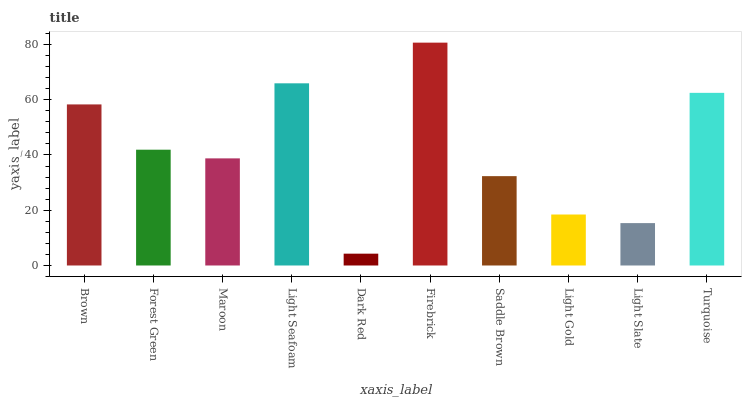Is Dark Red the minimum?
Answer yes or no. Yes. Is Firebrick the maximum?
Answer yes or no. Yes. Is Forest Green the minimum?
Answer yes or no. No. Is Forest Green the maximum?
Answer yes or no. No. Is Brown greater than Forest Green?
Answer yes or no. Yes. Is Forest Green less than Brown?
Answer yes or no. Yes. Is Forest Green greater than Brown?
Answer yes or no. No. Is Brown less than Forest Green?
Answer yes or no. No. Is Forest Green the high median?
Answer yes or no. Yes. Is Maroon the low median?
Answer yes or no. Yes. Is Light Seafoam the high median?
Answer yes or no. No. Is Brown the low median?
Answer yes or no. No. 